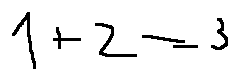<formula> <loc_0><loc_0><loc_500><loc_500>1 + 2 = 3</formula> 